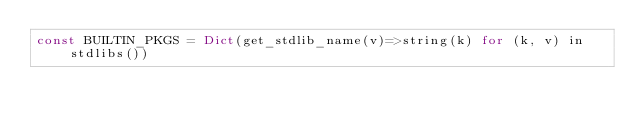Convert code to text. <code><loc_0><loc_0><loc_500><loc_500><_Julia_>const BUILTIN_PKGS = Dict(get_stdlib_name(v)=>string(k) for (k, v) in stdlibs())
</code> 